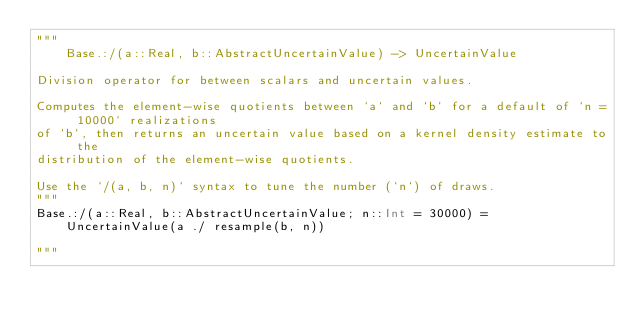<code> <loc_0><loc_0><loc_500><loc_500><_Julia_>"""
    Base.:/(a::Real, b::AbstractUncertainValue) -> UncertainValue

Division operator for between scalars and uncertain values. 

Computes the element-wise quotients between `a` and `b` for a default of `n = 10000` realizations
of `b`, then returns an uncertain value based on a kernel density estimate to the 
distribution of the element-wise quotients.
    
Use the `/(a, b, n)` syntax to tune the number (`n`) of draws.
"""
Base.:/(a::Real, b::AbstractUncertainValue; n::Int = 30000) = 
    UncertainValue(a ./ resample(b, n))

"""</code> 